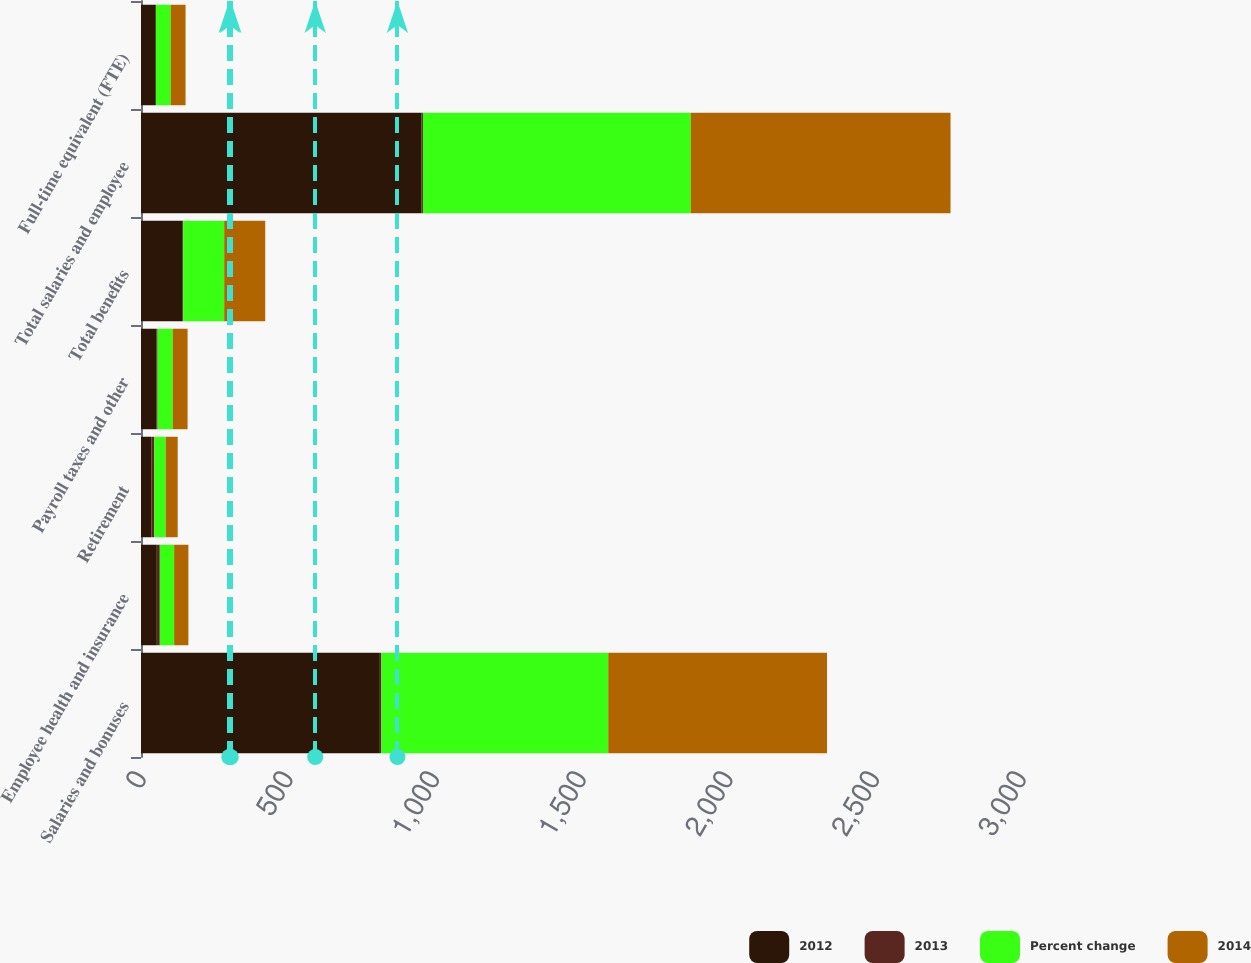Convert chart. <chart><loc_0><loc_0><loc_500><loc_500><stacked_bar_chart><ecel><fcel>Salaries and bonuses<fcel>Employee health and insurance<fcel>Retirement<fcel>Payroll taxes and other<fcel>Total benefits<fcel>Total salaries and employee<fcel>Full-time equivalent (FTE)<nl><fcel>2012<fcel>814.2<fcel>53.9<fcel>35<fcel>53.3<fcel>142.2<fcel>956.4<fcel>50.6<nl><fcel>2013<fcel>5.3<fcel>10.2<fcel>10.3<fcel>3.3<fcel>1.9<fcel>4.8<fcel>0.1<nl><fcel>Percent change<fcel>773.4<fcel>48.9<fcel>39<fcel>51.6<fcel>139.5<fcel>912.9<fcel>50.6<nl><fcel>2014<fcel>745.7<fcel>48.6<fcel>40.8<fcel>50.6<fcel>140<fcel>885.7<fcel>50.6<nl></chart> 